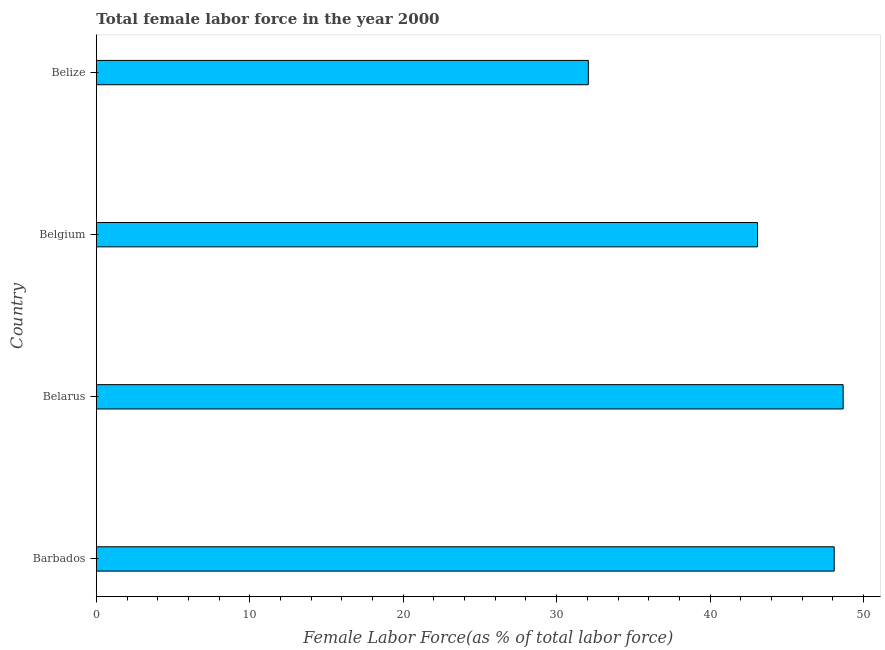What is the title of the graph?
Give a very brief answer. Total female labor force in the year 2000. What is the label or title of the X-axis?
Provide a short and direct response. Female Labor Force(as % of total labor force). What is the total female labor force in Belize?
Provide a succinct answer. 32.07. Across all countries, what is the maximum total female labor force?
Provide a short and direct response. 48.67. Across all countries, what is the minimum total female labor force?
Make the answer very short. 32.07. In which country was the total female labor force maximum?
Your response must be concise. Belarus. In which country was the total female labor force minimum?
Your response must be concise. Belize. What is the sum of the total female labor force?
Offer a terse response. 171.92. What is the difference between the total female labor force in Barbados and Belgium?
Your answer should be compact. 5. What is the average total female labor force per country?
Provide a succinct answer. 42.98. What is the median total female labor force?
Offer a very short reply. 45.59. In how many countries, is the total female labor force greater than 38 %?
Your answer should be very brief. 3. What is the ratio of the total female labor force in Belarus to that in Belgium?
Your response must be concise. 1.13. Is the total female labor force in Barbados less than that in Belgium?
Keep it short and to the point. No. What is the difference between the highest and the second highest total female labor force?
Make the answer very short. 0.58. What is the difference between the highest and the lowest total female labor force?
Keep it short and to the point. 16.61. In how many countries, is the total female labor force greater than the average total female labor force taken over all countries?
Give a very brief answer. 3. Are all the bars in the graph horizontal?
Provide a succinct answer. Yes. What is the difference between two consecutive major ticks on the X-axis?
Provide a short and direct response. 10. What is the Female Labor Force(as % of total labor force) of Barbados?
Keep it short and to the point. 48.09. What is the Female Labor Force(as % of total labor force) in Belarus?
Provide a short and direct response. 48.67. What is the Female Labor Force(as % of total labor force) in Belgium?
Make the answer very short. 43.09. What is the Female Labor Force(as % of total labor force) in Belize?
Keep it short and to the point. 32.07. What is the difference between the Female Labor Force(as % of total labor force) in Barbados and Belarus?
Offer a very short reply. -0.58. What is the difference between the Female Labor Force(as % of total labor force) in Barbados and Belgium?
Provide a short and direct response. 5. What is the difference between the Female Labor Force(as % of total labor force) in Barbados and Belize?
Keep it short and to the point. 16.02. What is the difference between the Female Labor Force(as % of total labor force) in Belarus and Belgium?
Your answer should be compact. 5.58. What is the difference between the Female Labor Force(as % of total labor force) in Belarus and Belize?
Provide a succinct answer. 16.61. What is the difference between the Female Labor Force(as % of total labor force) in Belgium and Belize?
Give a very brief answer. 11.02. What is the ratio of the Female Labor Force(as % of total labor force) in Barbados to that in Belarus?
Make the answer very short. 0.99. What is the ratio of the Female Labor Force(as % of total labor force) in Barbados to that in Belgium?
Ensure brevity in your answer.  1.12. What is the ratio of the Female Labor Force(as % of total labor force) in Belarus to that in Belgium?
Ensure brevity in your answer.  1.13. What is the ratio of the Female Labor Force(as % of total labor force) in Belarus to that in Belize?
Provide a short and direct response. 1.52. What is the ratio of the Female Labor Force(as % of total labor force) in Belgium to that in Belize?
Offer a terse response. 1.34. 